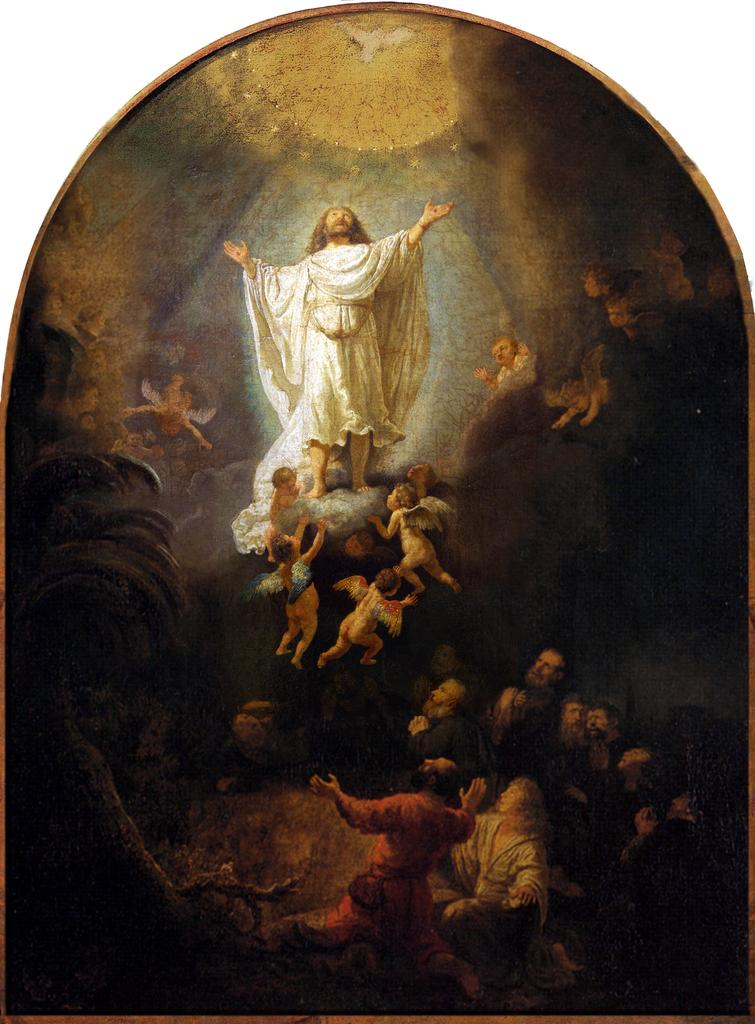What is the main subject of the painting in the image? The painting depicts people, a bird, and a tree. What is the color of the background in the painting? The background of the painting is white. What type of light is depicted in the painting? The painting depicts light. How many trees are being used as a whip in the painting? There are no trees being used as a whip in the painting; the painting depicts a single tree. What type of shade is provided by the bird in the painting? The painting depicts a bird, but it does not provide any shade; the bird is not associated with a source of shade in the image. 